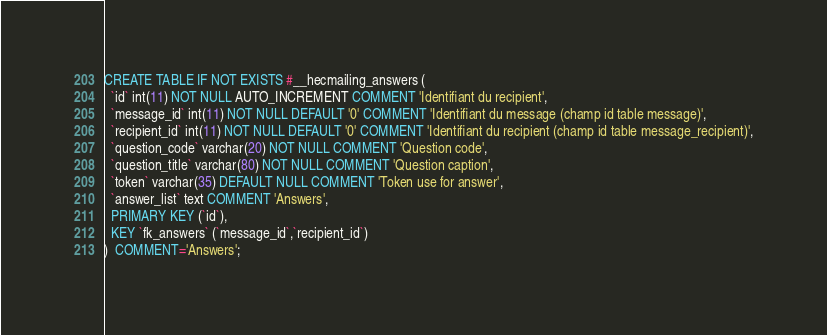Convert code to text. <code><loc_0><loc_0><loc_500><loc_500><_SQL_>CREATE TABLE IF NOT EXISTS #__hecmailing_answers (
  `id` int(11) NOT NULL AUTO_INCREMENT COMMENT 'Identifiant du recipient',
  `message_id` int(11) NOT NULL DEFAULT '0' COMMENT 'Identifiant du message (champ id table message)',
  `recipient_id` int(11) NOT NULL DEFAULT '0' COMMENT 'Identifiant du recipient (champ id table message_recipient)',
  `question_code` varchar(20) NOT NULL COMMENT 'Question code',
  `question_title` varchar(80) NOT NULL COMMENT 'Question caption',
  `token` varchar(35) DEFAULT NULL COMMENT 'Token use for answer',
  `answer_list` text COMMENT 'Answers',
  PRIMARY KEY (`id`),
  KEY `fk_answers` (`message_id`,`recipient_id`)
)  COMMENT='Answers';</code> 